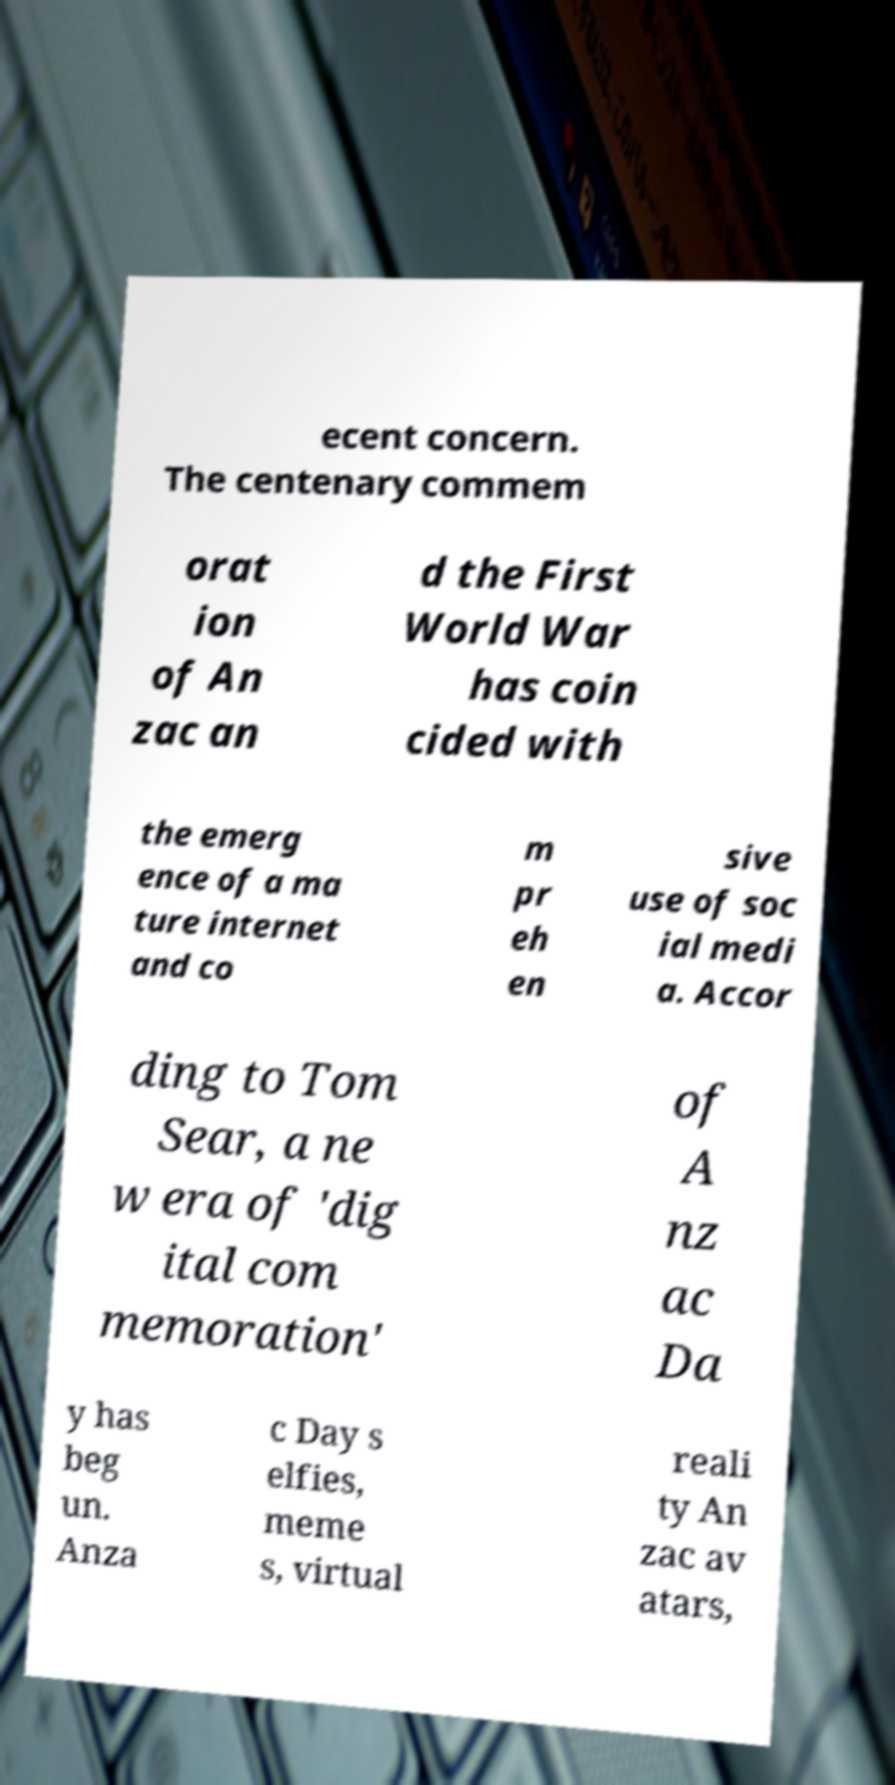Can you accurately transcribe the text from the provided image for me? ecent concern. The centenary commem orat ion of An zac an d the First World War has coin cided with the emerg ence of a ma ture internet and co m pr eh en sive use of soc ial medi a. Accor ding to Tom Sear, a ne w era of 'dig ital com memoration' of A nz ac Da y has beg un. Anza c Day s elfies, meme s, virtual reali ty An zac av atars, 